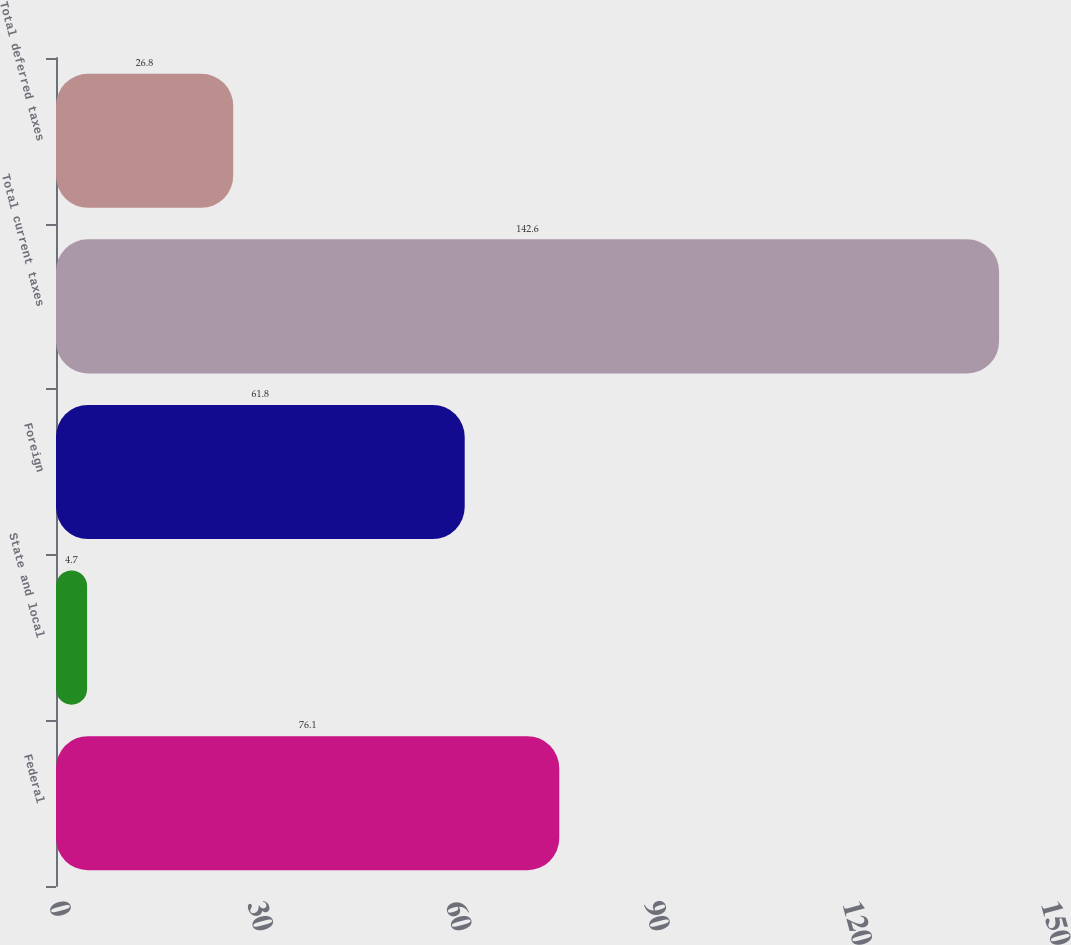<chart> <loc_0><loc_0><loc_500><loc_500><bar_chart><fcel>Federal<fcel>State and local<fcel>Foreign<fcel>Total current taxes<fcel>Total deferred taxes<nl><fcel>76.1<fcel>4.7<fcel>61.8<fcel>142.6<fcel>26.8<nl></chart> 